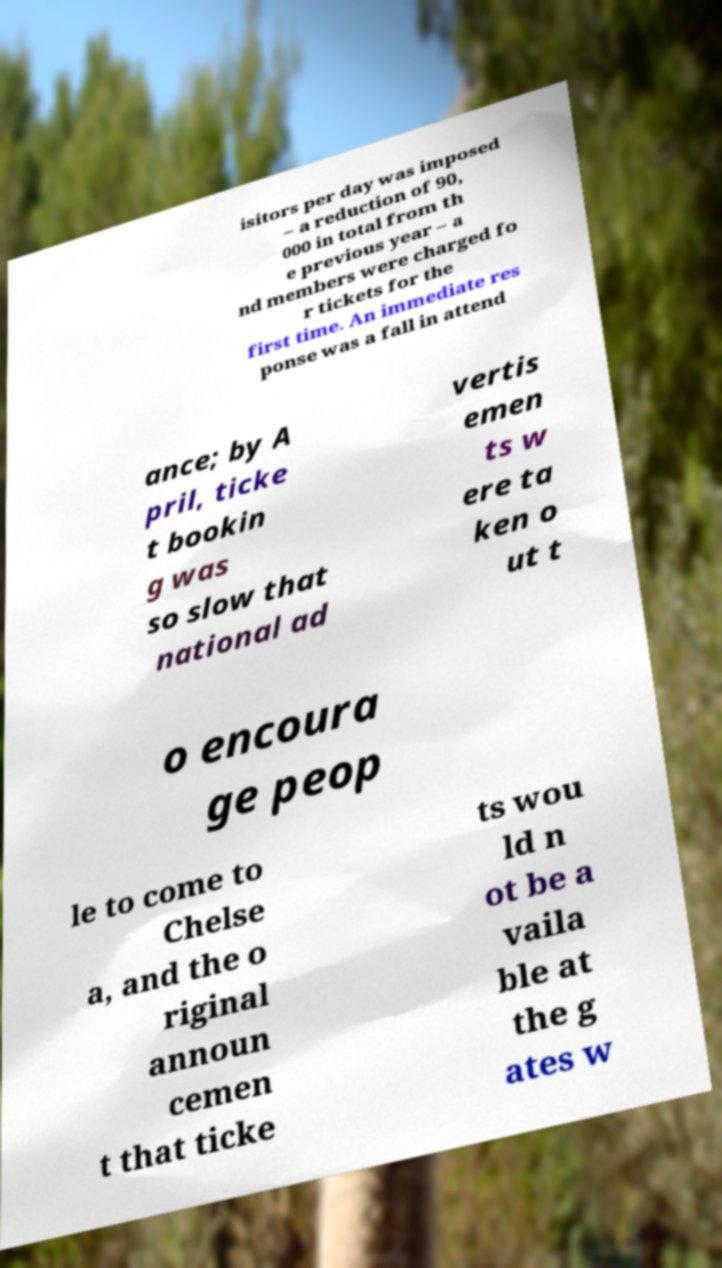Could you assist in decoding the text presented in this image and type it out clearly? isitors per day was imposed – a reduction of 90, 000 in total from th e previous year – a nd members were charged fo r tickets for the first time. An immediate res ponse was a fall in attend ance; by A pril, ticke t bookin g was so slow that national ad vertis emen ts w ere ta ken o ut t o encoura ge peop le to come to Chelse a, and the o riginal announ cemen t that ticke ts wou ld n ot be a vaila ble at the g ates w 